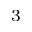Convert formula to latex. <formula><loc_0><loc_0><loc_500><loc_500>^ { 3 }</formula> 